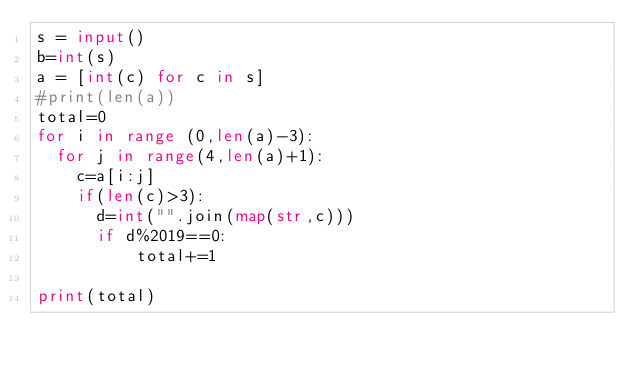<code> <loc_0><loc_0><loc_500><loc_500><_Python_>s = input()
b=int(s)
a = [int(c) for c in s]
#print(len(a))
total=0
for i in range (0,len(a)-3):
  for j in range(4,len(a)+1):
    c=a[i:j]
    if(len(c)>3):
    	d=int("".join(map(str,c)))
    	if d%2019==0:
          total+=1
          
print(total)
        </code> 